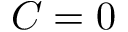<formula> <loc_0><loc_0><loc_500><loc_500>C = 0</formula> 